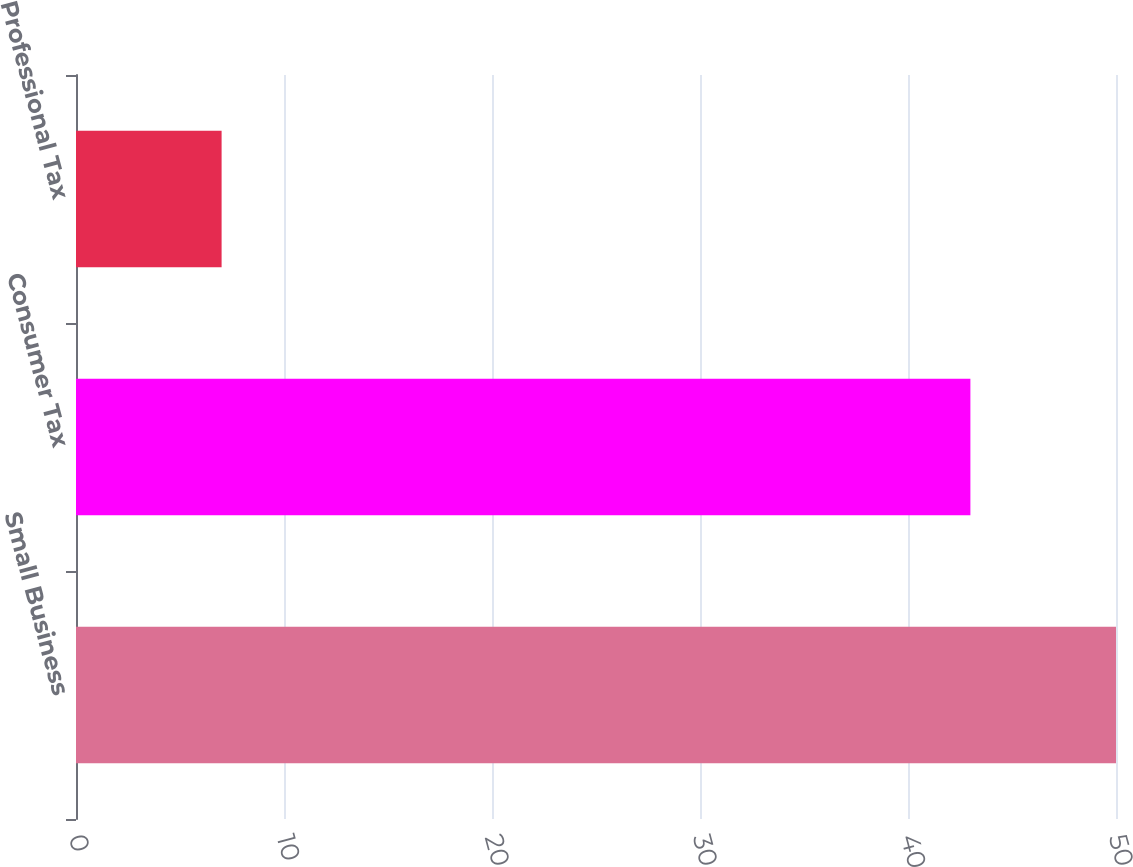Convert chart. <chart><loc_0><loc_0><loc_500><loc_500><bar_chart><fcel>Small Business<fcel>Consumer Tax<fcel>Professional Tax<nl><fcel>50<fcel>43<fcel>7<nl></chart> 